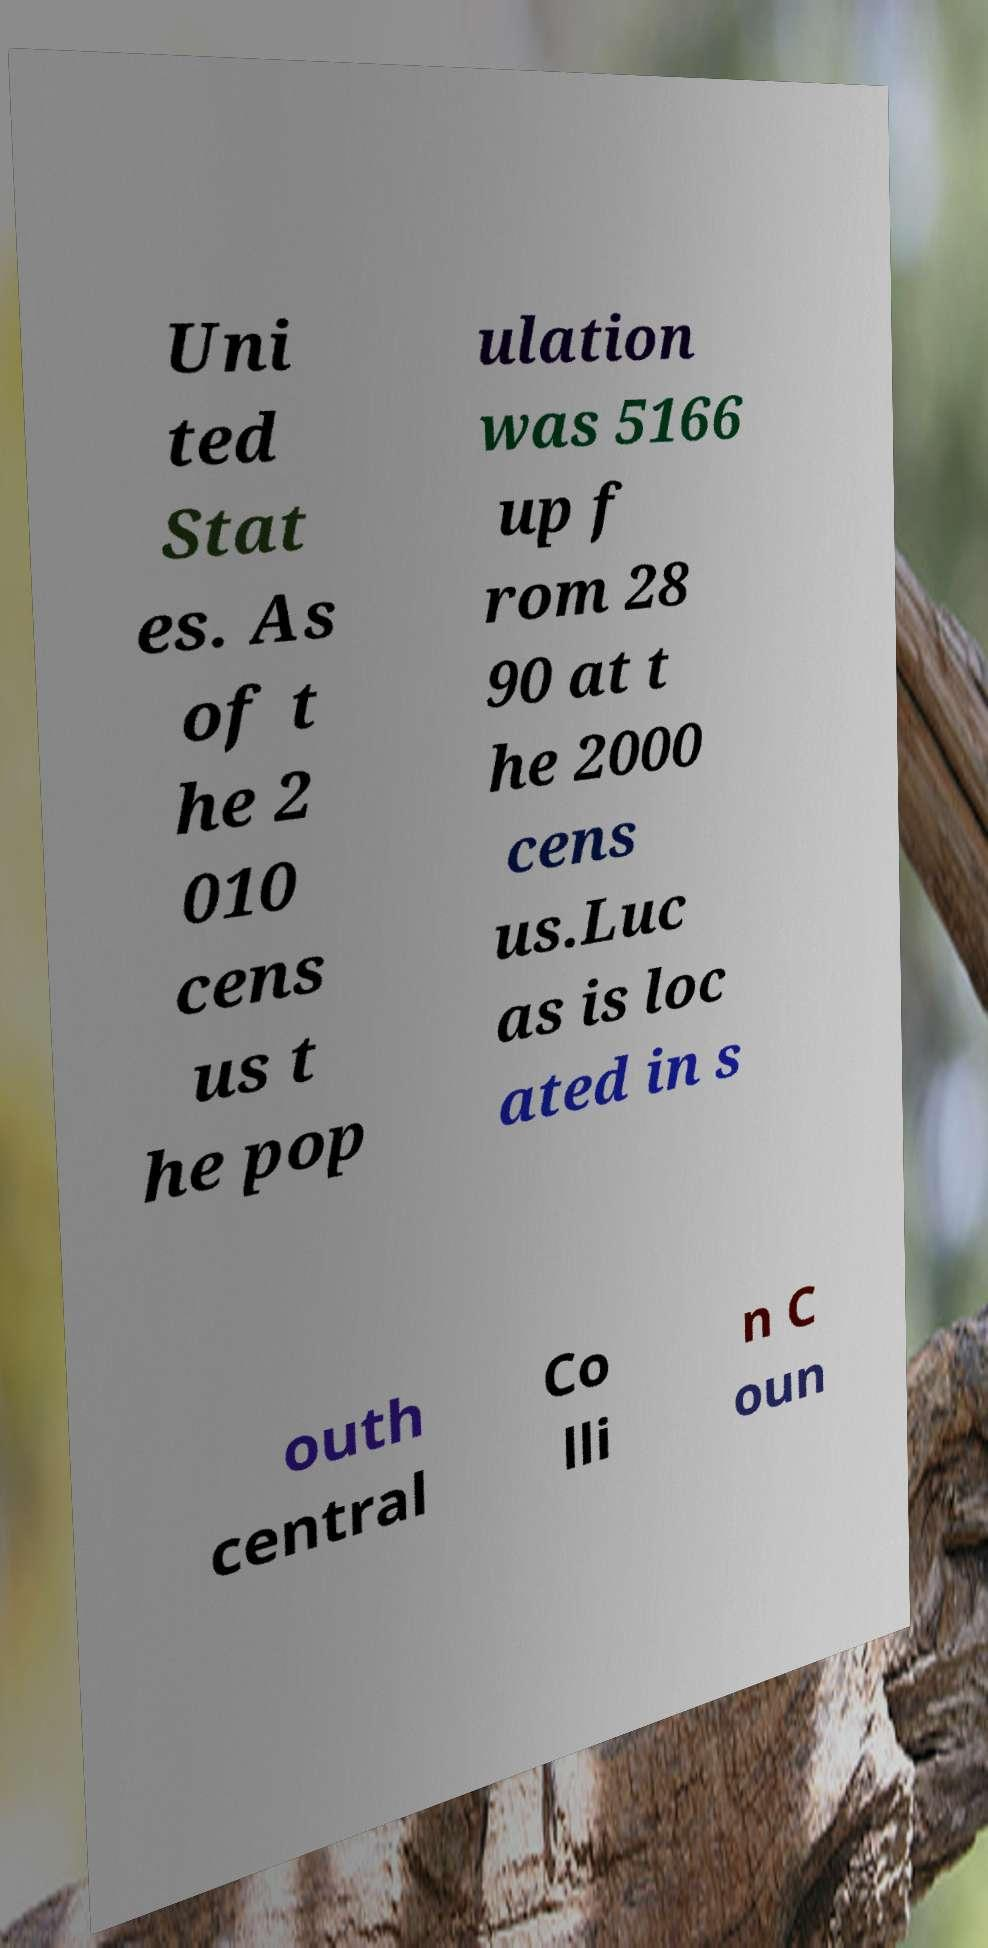I need the written content from this picture converted into text. Can you do that? Uni ted Stat es. As of t he 2 010 cens us t he pop ulation was 5166 up f rom 28 90 at t he 2000 cens us.Luc as is loc ated in s outh central Co lli n C oun 